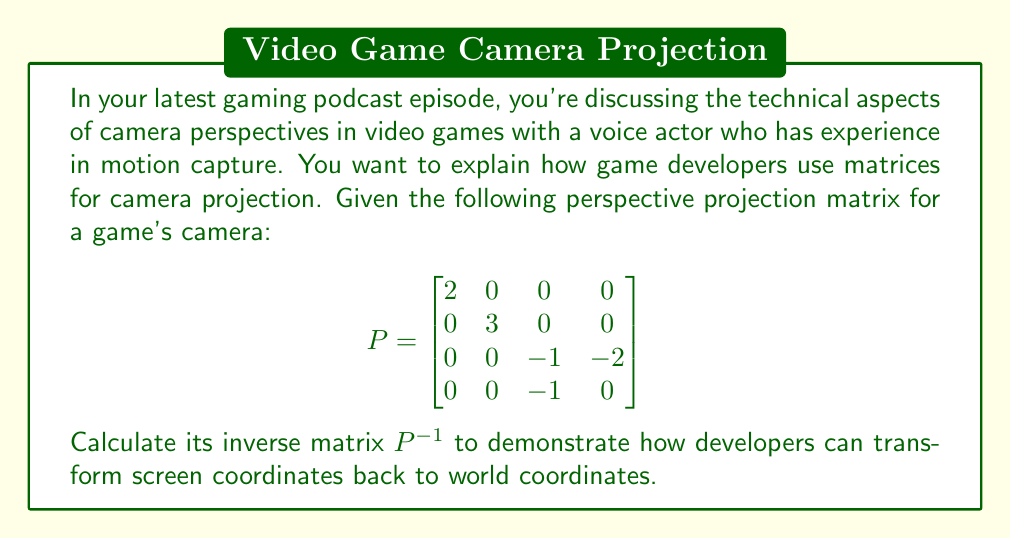Could you help me with this problem? To find the inverse of the 4x4 matrix P, we'll use the following steps:

1) First, we need to calculate the determinant of P. Given the structure of P, we can see that it's a block matrix:

   $$det(P) = det\begin{bmatrix}
   2 & 0 \\
   0 & 3
   \end{bmatrix} \cdot det\begin{bmatrix}
   -1 & -2 \\
   -1 & 0
   \end{bmatrix} = 6 \cdot 2 = 12$$

2) Now, we calculate the adjugate matrix. For a 4x4 matrix, this involves finding 16 3x3 determinants, but due to the structure of P, many of these will be zero:

   $$adj(P) = \begin{bmatrix}
   3 & 0 & 0 & 0 \\
   0 & 2 & 0 & 0 \\
   0 & 0 & 0 & -6 \\
   0 & 0 & 6 & -6
   \end{bmatrix}$$

3) The inverse is then given by:

   $$P^{-1} = \frac{1}{det(P)} \cdot adj(P) = \frac{1}{12} \begin{bmatrix}
   3 & 0 & 0 & 0 \\
   0 & 2 & 0 & 0 \\
   0 & 0 & 0 & -6 \\
   0 & 0 & 6 & -6
   \end{bmatrix}$$

4) Simplifying:

   $$P^{-1} = \begin{bmatrix}
   1/4 & 0 & 0 & 0 \\
   0 & 1/6 & 0 & 0 \\
   0 & 0 & 0 & -1/2 \\
   0 & 0 & 1/2 & -1/2
   \end{bmatrix}$$

This inverse matrix allows developers to transform coordinates from screen space back to world space, which is crucial for interactions between game objects and the camera view.
Answer: $$P^{-1} = \begin{bmatrix}
1/4 & 0 & 0 & 0 \\
0 & 1/6 & 0 & 0 \\
0 & 0 & 0 & -1/2 \\
0 & 0 & 1/2 & -1/2
\end{bmatrix}$$ 